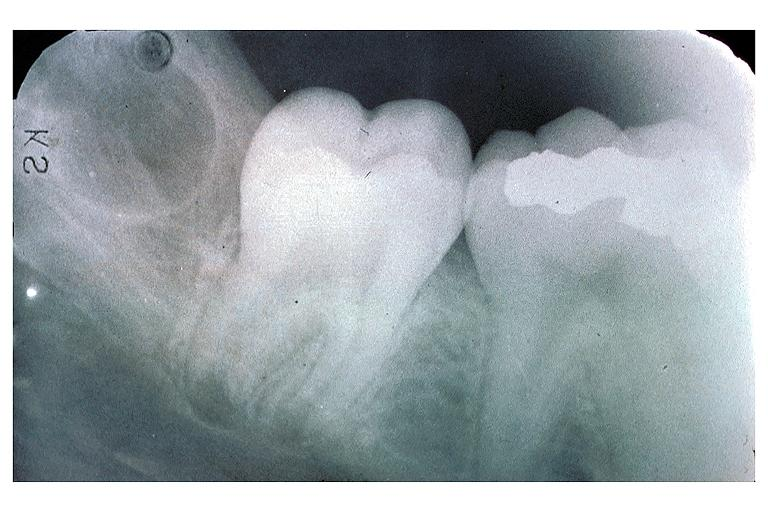s ulcer due to tube present?
Answer the question using a single word or phrase. No 